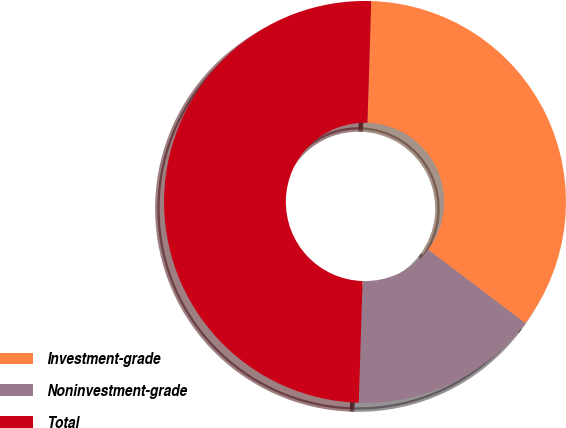Convert chart to OTSL. <chart><loc_0><loc_0><loc_500><loc_500><pie_chart><fcel>Investment-grade<fcel>Noninvestment-grade<fcel>Total<nl><fcel>34.82%<fcel>15.18%<fcel>50.0%<nl></chart> 